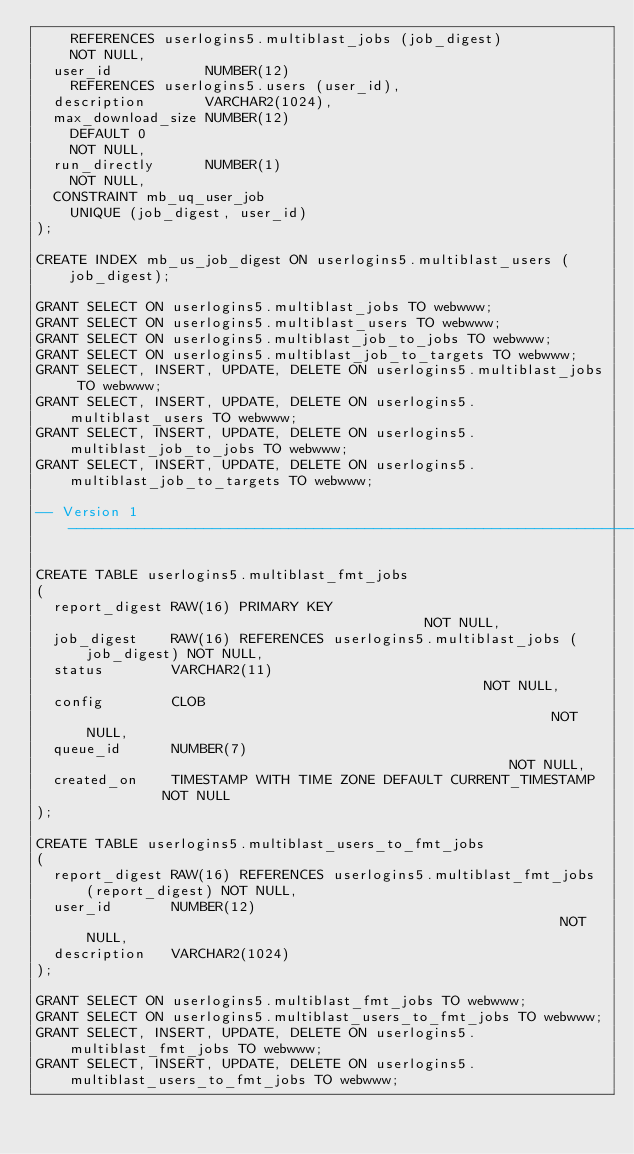<code> <loc_0><loc_0><loc_500><loc_500><_SQL_>    REFERENCES userlogins5.multiblast_jobs (job_digest)
    NOT NULL,
  user_id           NUMBER(12)
    REFERENCES userlogins5.users (user_id),
  description       VARCHAR2(1024),
  max_download_size NUMBER(12)
    DEFAULT 0
    NOT NULL,
  run_directly      NUMBER(1)
    NOT NULL,
  CONSTRAINT mb_uq_user_job
    UNIQUE (job_digest, user_id)
);

CREATE INDEX mb_us_job_digest ON userlogins5.multiblast_users (job_digest);

GRANT SELECT ON userlogins5.multiblast_jobs TO webwww;
GRANT SELECT ON userlogins5.multiblast_users TO webwww;
GRANT SELECT ON userlogins5.multiblast_job_to_jobs TO webwww;
GRANT SELECT ON userlogins5.multiblast_job_to_targets TO webwww;
GRANT SELECT, INSERT, UPDATE, DELETE ON userlogins5.multiblast_jobs TO webwww;
GRANT SELECT, INSERT, UPDATE, DELETE ON userlogins5.multiblast_users TO webwww;
GRANT SELECT, INSERT, UPDATE, DELETE ON userlogins5.multiblast_job_to_jobs TO webwww;
GRANT SELECT, INSERT, UPDATE, DELETE ON userlogins5.multiblast_job_to_targets TO webwww;

-- Version 1 ---------------------------------------------------------------------------------------

CREATE TABLE userlogins5.multiblast_fmt_jobs
(
  report_digest RAW(16) PRIMARY KEY                                         NOT NULL,
  job_digest    RAW(16) REFERENCES userlogins5.multiblast_jobs (job_digest) NOT NULL,
  status        VARCHAR2(11)                                                NOT NULL,
  config        CLOB                                                        NOT NULL,
  queue_id      NUMBER(7)                                                   NOT NULL,
  created_on    TIMESTAMP WITH TIME ZONE DEFAULT CURRENT_TIMESTAMP          NOT NULL
);

CREATE TABLE userlogins5.multiblast_users_to_fmt_jobs
(
  report_digest RAW(16) REFERENCES userlogins5.multiblast_fmt_jobs (report_digest) NOT NULL,
  user_id       NUMBER(12)                                                         NOT NULL,
  description   VARCHAR2(1024)
);

GRANT SELECT ON userlogins5.multiblast_fmt_jobs TO webwww;
GRANT SELECT ON userlogins5.multiblast_users_to_fmt_jobs TO webwww;
GRANT SELECT, INSERT, UPDATE, DELETE ON userlogins5.multiblast_fmt_jobs TO webwww;
GRANT SELECT, INSERT, UPDATE, DELETE ON userlogins5.multiblast_users_to_fmt_jobs TO webwww;
</code> 